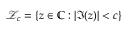<formula> <loc_0><loc_0><loc_500><loc_500>\mathcal { Z } _ { c } = \{ z \in \mathbb { C } \colon | \Im ( z ) | < c \}</formula> 